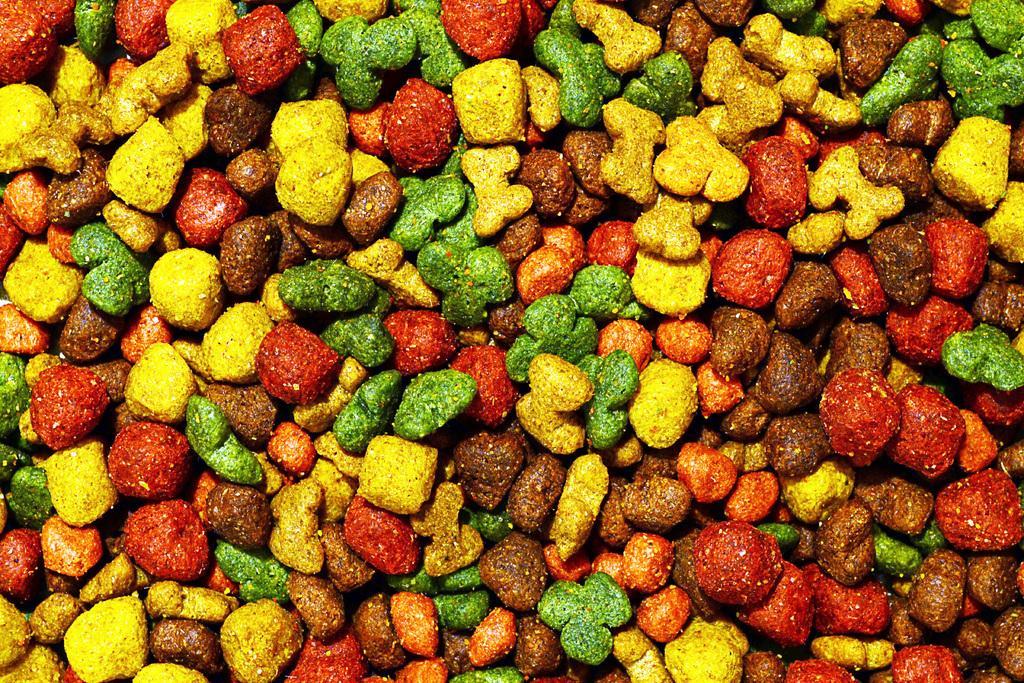In one or two sentences, can you explain what this image depicts? It is a zoomed in picture of colorful candies. 